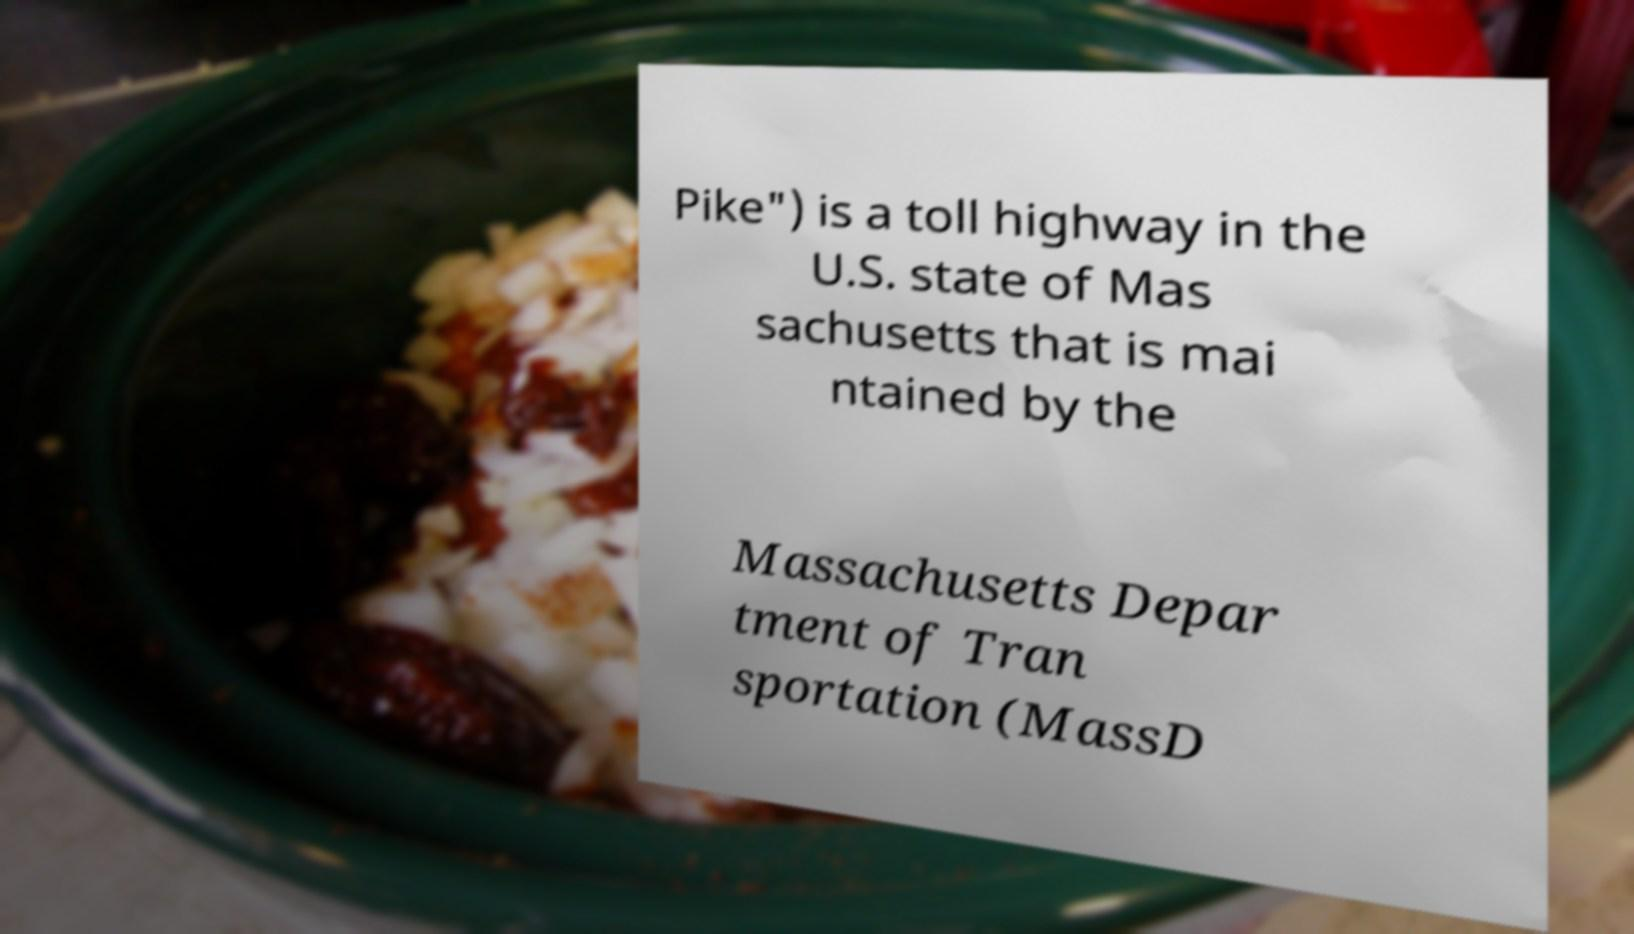Could you extract and type out the text from this image? Pike") is a toll highway in the U.S. state of Mas sachusetts that is mai ntained by the Massachusetts Depar tment of Tran sportation (MassD 